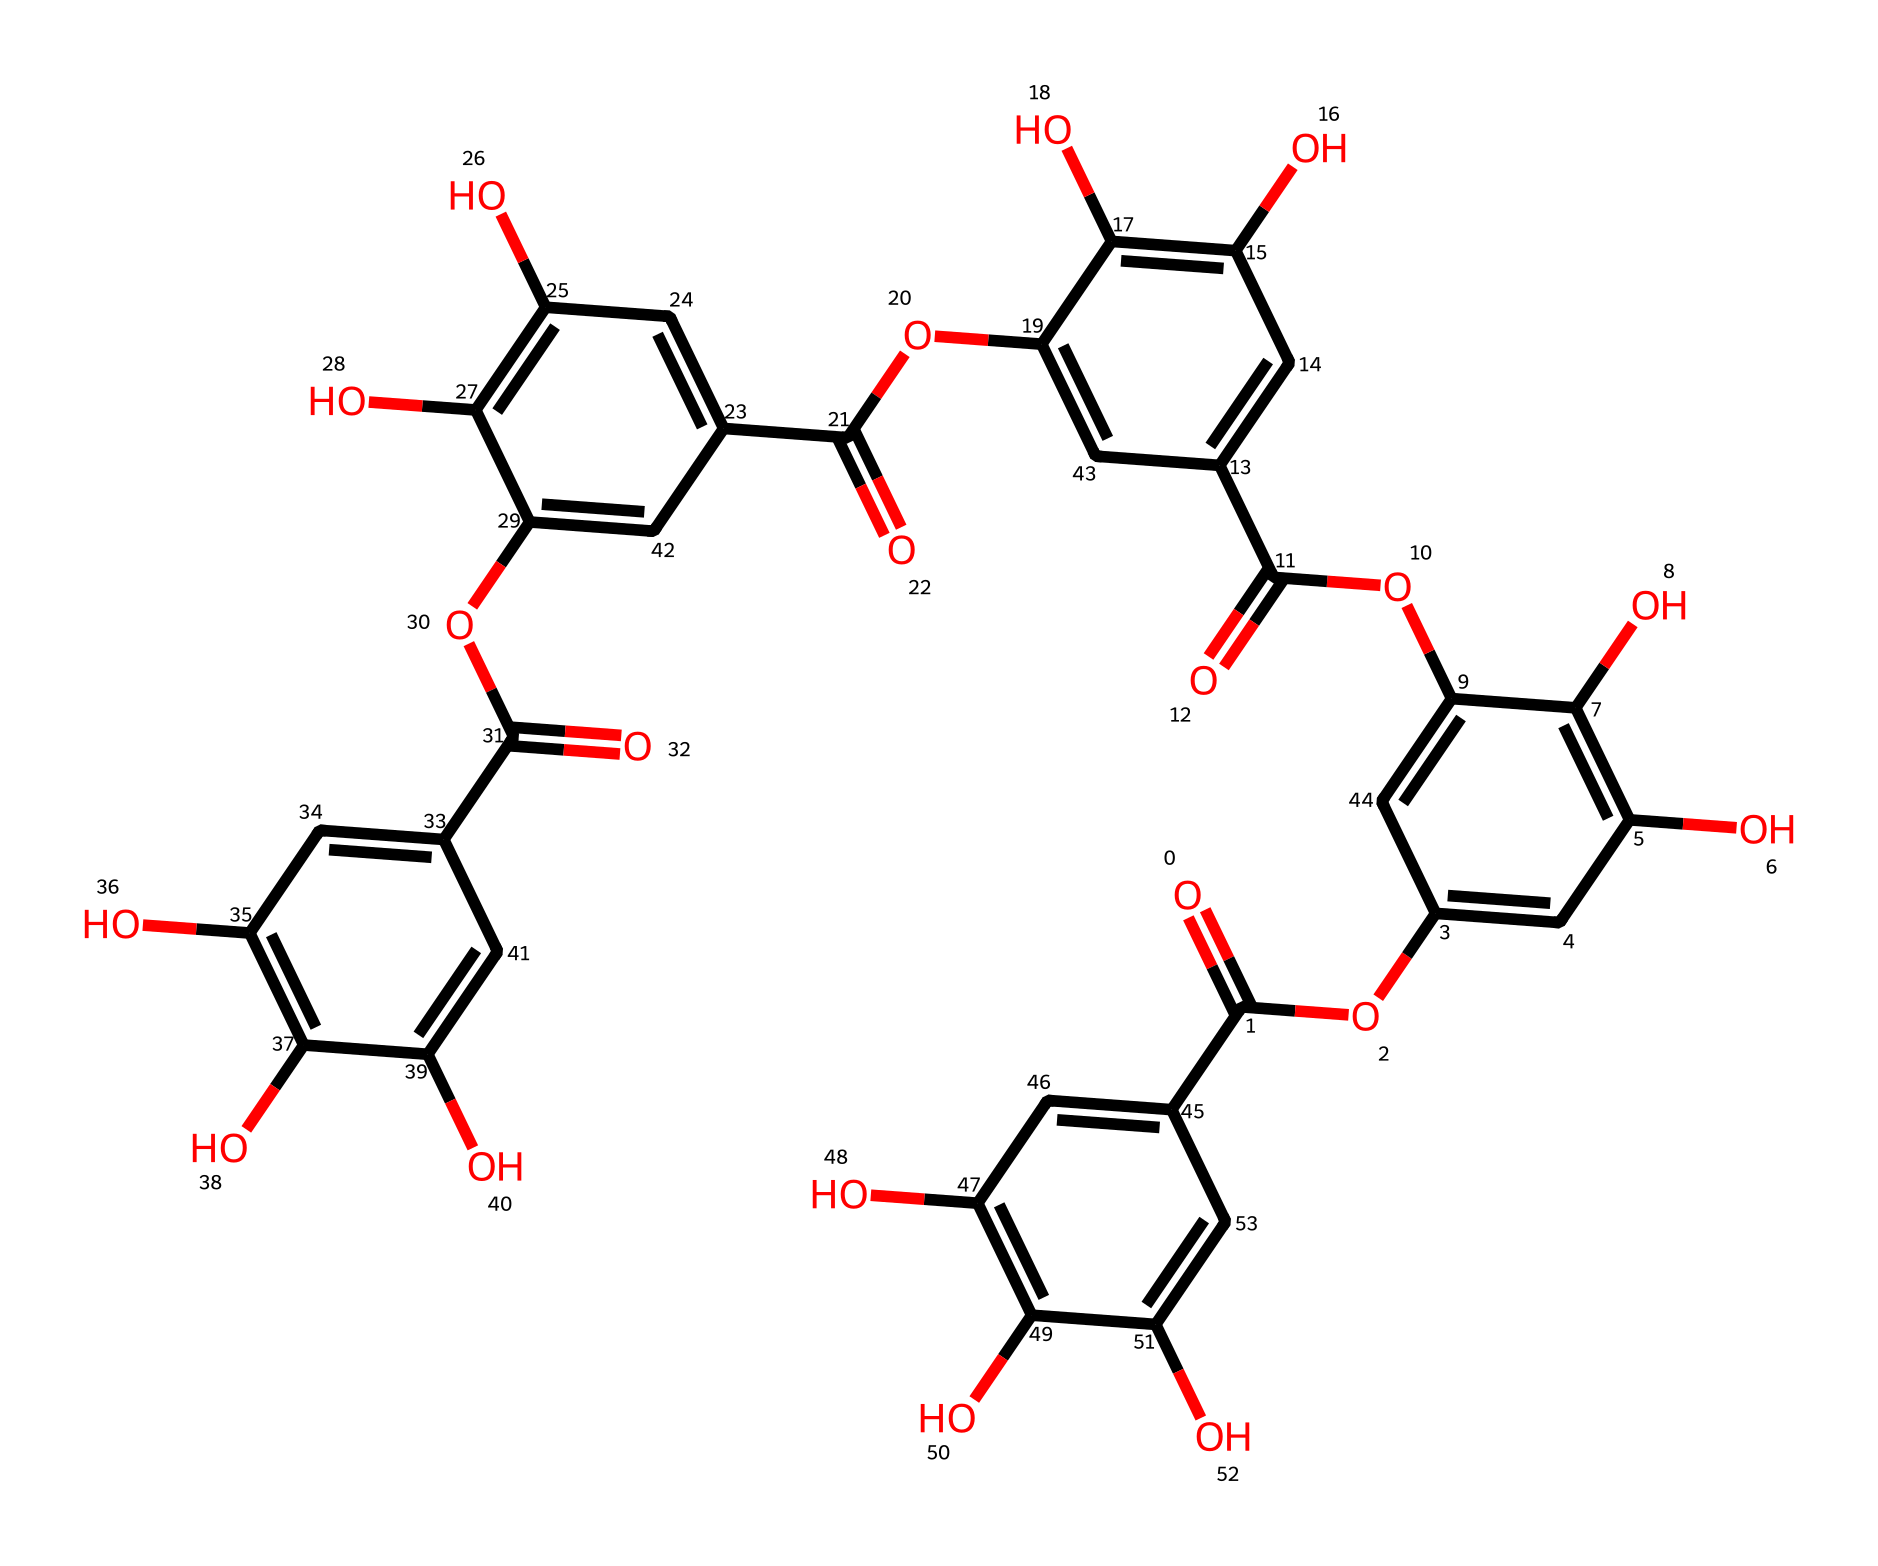What is the molecular formula of tannic acid? To determine the molecular formula, one must analyze the structure provided by the SMILES representation to count the occurrences of each atom type. After thorough examination, the molecular formula of tannic acid can be derived as C76H52O46.
Answer: C76H52O46 How many hydroxyl (-OH) groups are present in tannic acid? In the structure of tannic acid, each -OH group corresponds to a hydroxyl functional group. By tracing the carbon rings and identifying each -OH present, one can count a total of 10 hydroxyl groups in the structure.
Answer: 10 What type of functional groups are primarily found in tannic acid? Upon reviewing the chemical structure of tannic acid, one can identify the presence of carboxyl (-COOH) and hydroxyl (-OH) functional groups. These groups serve as the defining features of acids and contribute to its acidic properties.
Answer: carboxyl and hydroxyl Is tannic acid a simple or complex acid? The complexity of an acid can be inferred from the structure and the number of functional groups present. Tannic acid, with its intricate structure comprising multiple interconnected phenolic units and several functional groups, is considered a complex acid.
Answer: complex How does the structure of tannic acid influence its solubility? The solubility of tannic acid can be explained by its multiple hydroxyl groups and polar nature, which increases interaction with water molecules. This makes tannic acid relatively soluble in polar solvents like water, owing to its structural features promoting hydrogen bonding.
Answer: polar What effect does the presence of multiple aromatic rings have on the properties of tannic acid? The presence of multiple aromatic rings lends to tannic acid's ability to undergo π- π stacking interactions, enhancing its stability and solubility. Furthermore, these rings contribute to the chemical's astringent property and its characteristic dark hue, relevant in vintage writing inks.
Answer: astringent property 